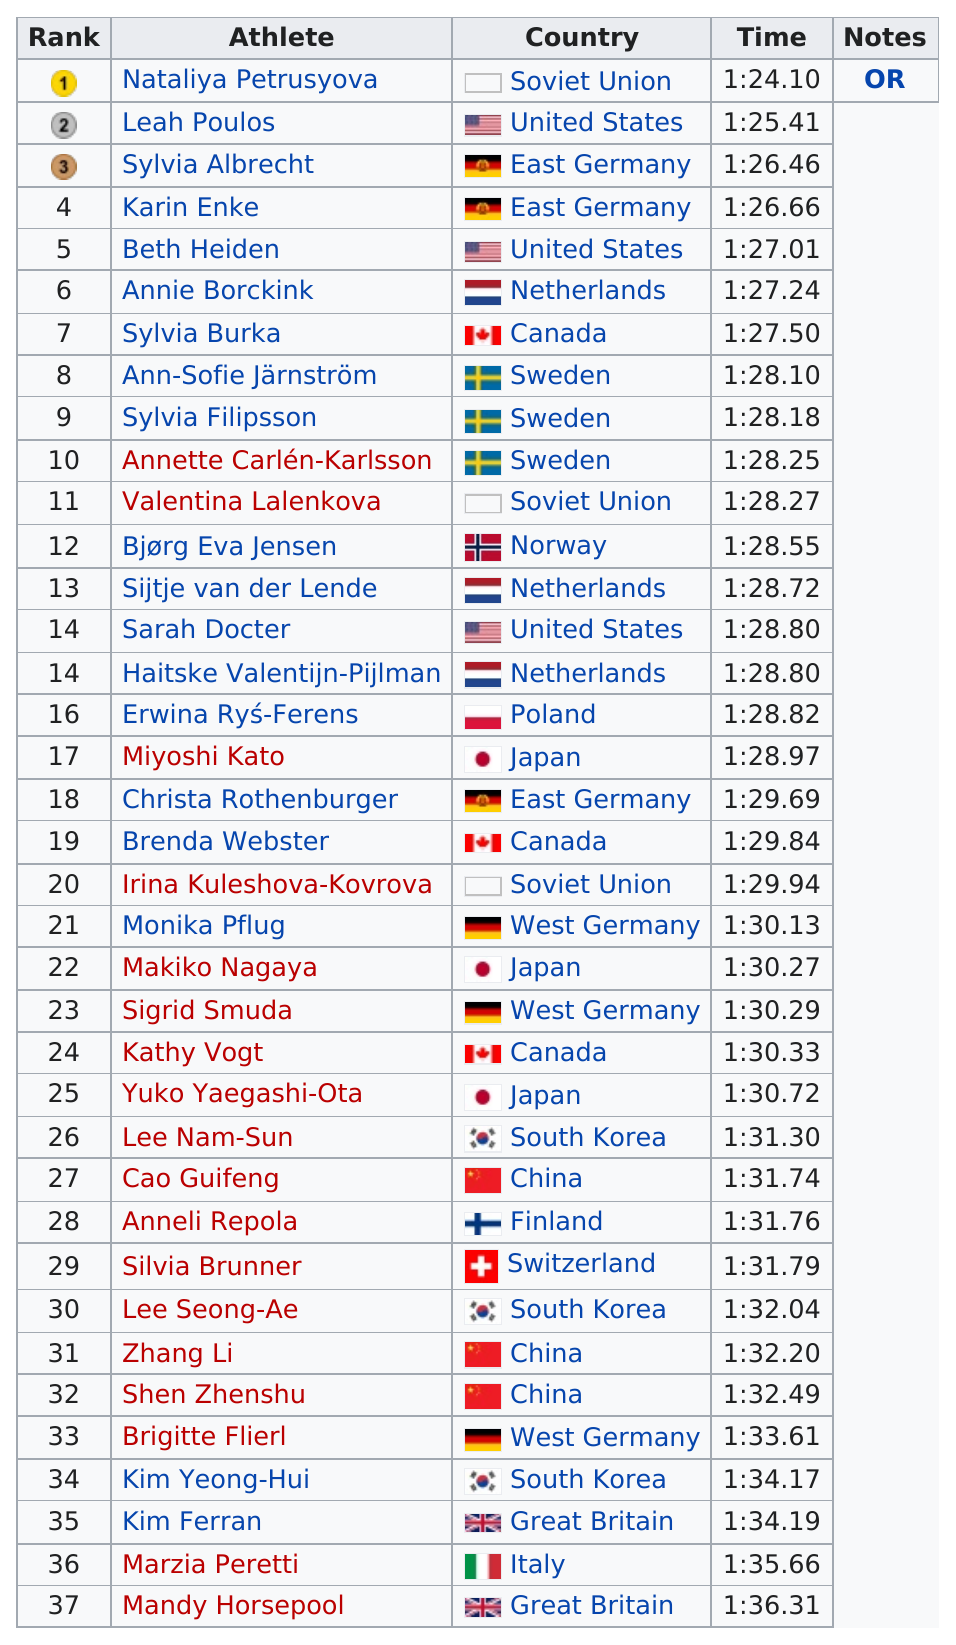Identify some key points in this picture. Karin Enke finished the race in a time of 1 hour and 26 minutes and 66 thousandths of a second. Sylvia Albrecht was the bronze medalist for East Germany in a competition. Nataliya Petrusyova won first place in the women's 1000 metres in speed skating at the 1980 Winter Olympics. Thirty athletes from East Germany are participating in the event. The fastest time in the competition was 1:24.10. 